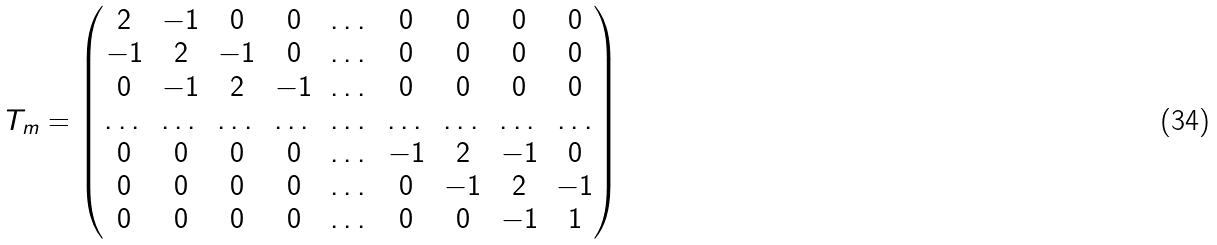Convert formula to latex. <formula><loc_0><loc_0><loc_500><loc_500>T _ { m } = \begin{pmatrix} 2 & - 1 & 0 & 0 & \dots & 0 & 0 & 0 & 0 \\ - 1 & 2 & - 1 & 0 & \dots & 0 & 0 & 0 & 0 \\ 0 & - 1 & 2 & - 1 & \dots & 0 & 0 & 0 & 0 \\ \dots & \dots & \dots & \dots & \dots & \dots & \dots & \dots & \dots \\ 0 & 0 & 0 & 0 & \dots & - 1 & 2 & - 1 & 0 \\ 0 & 0 & 0 & 0 & \dots & 0 & - 1 & 2 & - 1 \\ 0 & 0 & 0 & 0 & \dots & 0 & 0 & - 1 & 1 \end{pmatrix}</formula> 